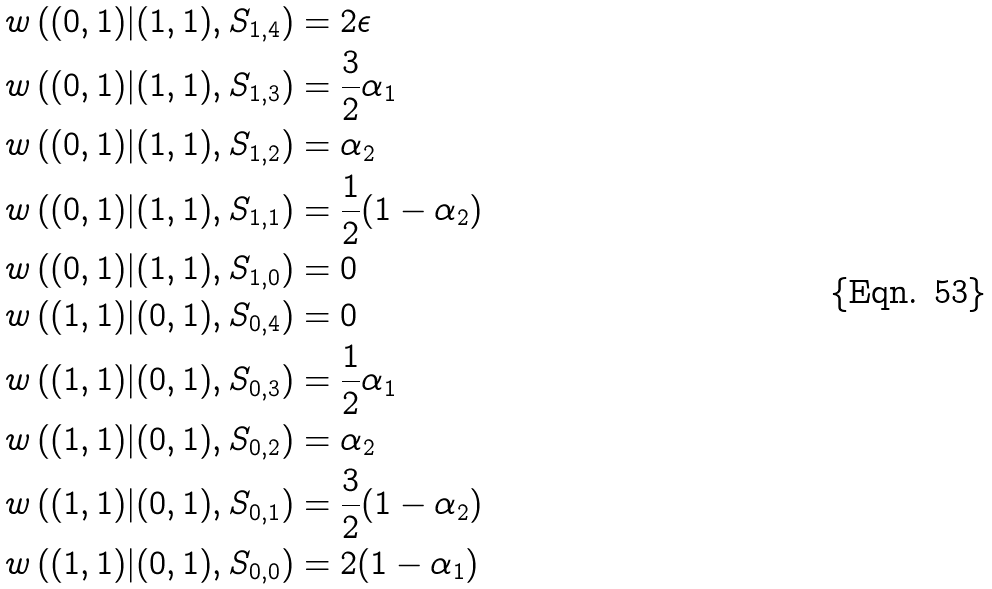Convert formula to latex. <formula><loc_0><loc_0><loc_500><loc_500>w \left ( ( 0 , 1 ) | ( 1 , 1 ) , S _ { 1 , 4 } \right ) & = 2 \epsilon \\ w \left ( ( 0 , 1 ) | ( 1 , 1 ) , S _ { 1 , 3 } \right ) & = \frac { 3 } { 2 } \alpha _ { 1 } \\ w \left ( ( 0 , 1 ) | ( 1 , 1 ) , S _ { 1 , 2 } \right ) & = \alpha _ { 2 } \\ w \left ( ( 0 , 1 ) | ( 1 , 1 ) , S _ { 1 , 1 } \right ) & = \frac { 1 } { 2 } ( 1 - \alpha _ { 2 } ) \\ w \left ( ( 0 , 1 ) | ( 1 , 1 ) , S _ { 1 , 0 } \right ) & = 0 \\ w \left ( ( 1 , 1 ) | ( 0 , 1 ) , S _ { 0 , 4 } \right ) & = 0 \\ w \left ( ( 1 , 1 ) | ( 0 , 1 ) , S _ { 0 , 3 } \right ) & = \frac { 1 } { 2 } \alpha _ { 1 } \\ w \left ( ( 1 , 1 ) | ( 0 , 1 ) , S _ { 0 , 2 } \right ) & = \alpha _ { 2 } \\ w \left ( ( 1 , 1 ) | ( 0 , 1 ) , S _ { 0 , 1 } \right ) & = \frac { 3 } { 2 } ( 1 - \alpha _ { 2 } ) \\ w \left ( ( 1 , 1 ) | ( 0 , 1 ) , S _ { 0 , 0 } \right ) & = 2 ( 1 - \alpha _ { 1 } )</formula> 